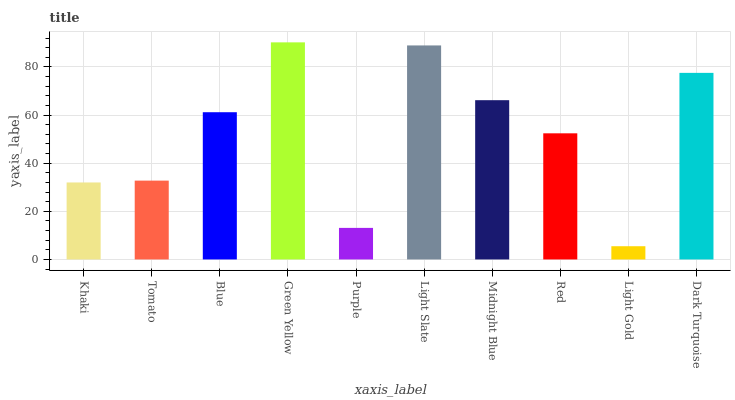Is Light Gold the minimum?
Answer yes or no. Yes. Is Green Yellow the maximum?
Answer yes or no. Yes. Is Tomato the minimum?
Answer yes or no. No. Is Tomato the maximum?
Answer yes or no. No. Is Tomato greater than Khaki?
Answer yes or no. Yes. Is Khaki less than Tomato?
Answer yes or no. Yes. Is Khaki greater than Tomato?
Answer yes or no. No. Is Tomato less than Khaki?
Answer yes or no. No. Is Blue the high median?
Answer yes or no. Yes. Is Red the low median?
Answer yes or no. Yes. Is Light Slate the high median?
Answer yes or no. No. Is Khaki the low median?
Answer yes or no. No. 